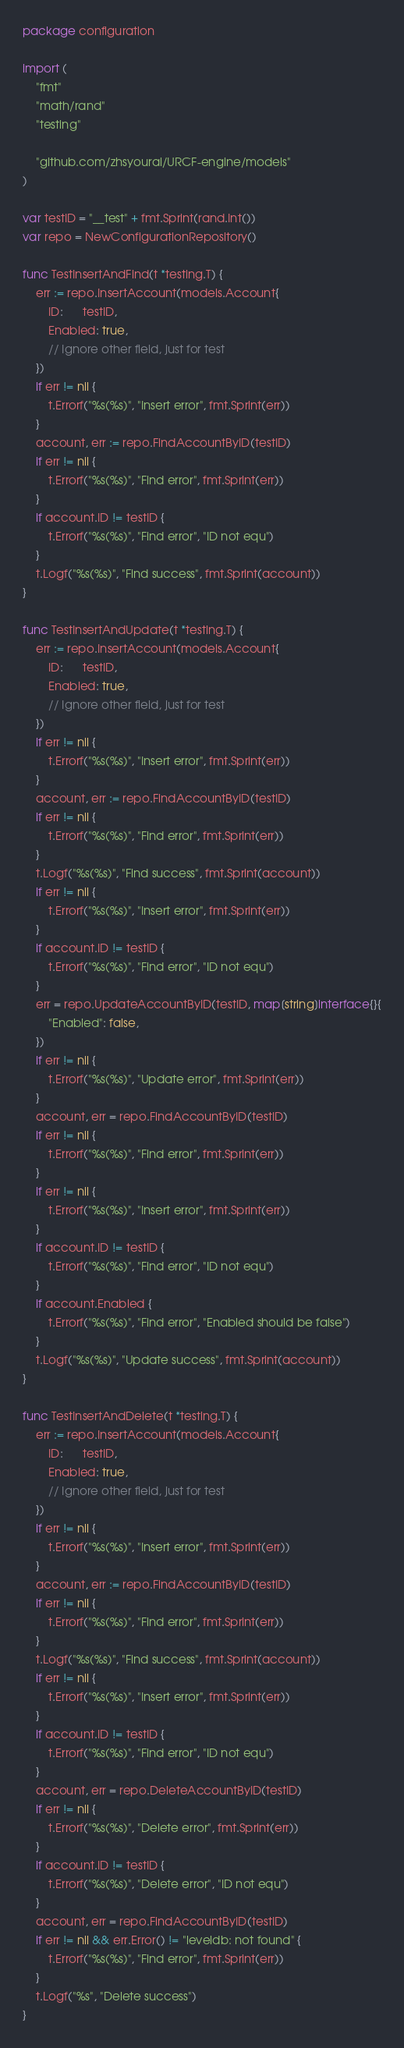Convert code to text. <code><loc_0><loc_0><loc_500><loc_500><_Go_>package configuration

import (
	"fmt"
	"math/rand"
	"testing"

	"github.com/zhsyourai/URCF-engine/models"
)

var testID = "__test" + fmt.Sprint(rand.Int())
var repo = NewConfigurationRepository()

func TestInsertAndFind(t *testing.T) {
	err := repo.InsertAccount(models.Account{
		ID:      testID,
		Enabled: true,
		// Ignore other field, just for test
	})
	if err != nil {
		t.Errorf("%s(%s)", "Insert error", fmt.Sprint(err))
	}
	account, err := repo.FindAccountByID(testID)
	if err != nil {
		t.Errorf("%s(%s)", "Find error", fmt.Sprint(err))
	}
	if account.ID != testID {
		t.Errorf("%s(%s)", "Find error", "ID not equ")
	}
	t.Logf("%s(%s)", "Find success", fmt.Sprint(account))
}

func TestInsertAndUpdate(t *testing.T) {
	err := repo.InsertAccount(models.Account{
		ID:      testID,
		Enabled: true,
		// Ignore other field, just for test
	})
	if err != nil {
		t.Errorf("%s(%s)", "Insert error", fmt.Sprint(err))
	}
	account, err := repo.FindAccountByID(testID)
	if err != nil {
		t.Errorf("%s(%s)", "Find error", fmt.Sprint(err))
	}
	t.Logf("%s(%s)", "Find success", fmt.Sprint(account))
	if err != nil {
		t.Errorf("%s(%s)", "Insert error", fmt.Sprint(err))
	}
	if account.ID != testID {
		t.Errorf("%s(%s)", "Find error", "ID not equ")
	}
	err = repo.UpdateAccountByID(testID, map[string]interface{}{
		"Enabled": false,
	})
	if err != nil {
		t.Errorf("%s(%s)", "Update error", fmt.Sprint(err))
	}
	account, err = repo.FindAccountByID(testID)
	if err != nil {
		t.Errorf("%s(%s)", "Find error", fmt.Sprint(err))
	}
	if err != nil {
		t.Errorf("%s(%s)", "Insert error", fmt.Sprint(err))
	}
	if account.ID != testID {
		t.Errorf("%s(%s)", "Find error", "ID not equ")
	}
	if account.Enabled {
		t.Errorf("%s(%s)", "Find error", "Enabled should be false")
	}
	t.Logf("%s(%s)", "Update success", fmt.Sprint(account))
}

func TestInsertAndDelete(t *testing.T) {
	err := repo.InsertAccount(models.Account{
		ID:      testID,
		Enabled: true,
		// Ignore other field, just for test
	})
	if err != nil {
		t.Errorf("%s(%s)", "Insert error", fmt.Sprint(err))
	}
	account, err := repo.FindAccountByID(testID)
	if err != nil {
		t.Errorf("%s(%s)", "Find error", fmt.Sprint(err))
	}
	t.Logf("%s(%s)", "Find success", fmt.Sprint(account))
	if err != nil {
		t.Errorf("%s(%s)", "Insert error", fmt.Sprint(err))
	}
	if account.ID != testID {
		t.Errorf("%s(%s)", "Find error", "ID not equ")
	}
	account, err = repo.DeleteAccountByID(testID)
	if err != nil {
		t.Errorf("%s(%s)", "Delete error", fmt.Sprint(err))
	}
	if account.ID != testID {
		t.Errorf("%s(%s)", "Delete error", "ID not equ")
	}
	account, err = repo.FindAccountByID(testID)
	if err != nil && err.Error() != "leveldb: not found" {
		t.Errorf("%s(%s)", "Find error", fmt.Sprint(err))
	}
	t.Logf("%s", "Delete success")
}
</code> 